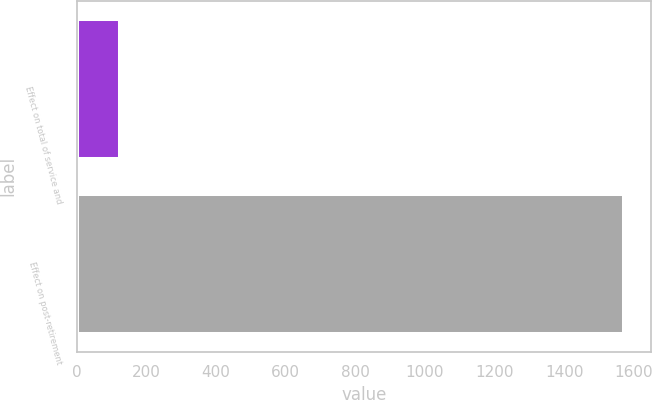Convert chart to OTSL. <chart><loc_0><loc_0><loc_500><loc_500><bar_chart><fcel>Effect on total of service and<fcel>Effect on post-retirement<nl><fcel>123<fcel>1571<nl></chart> 